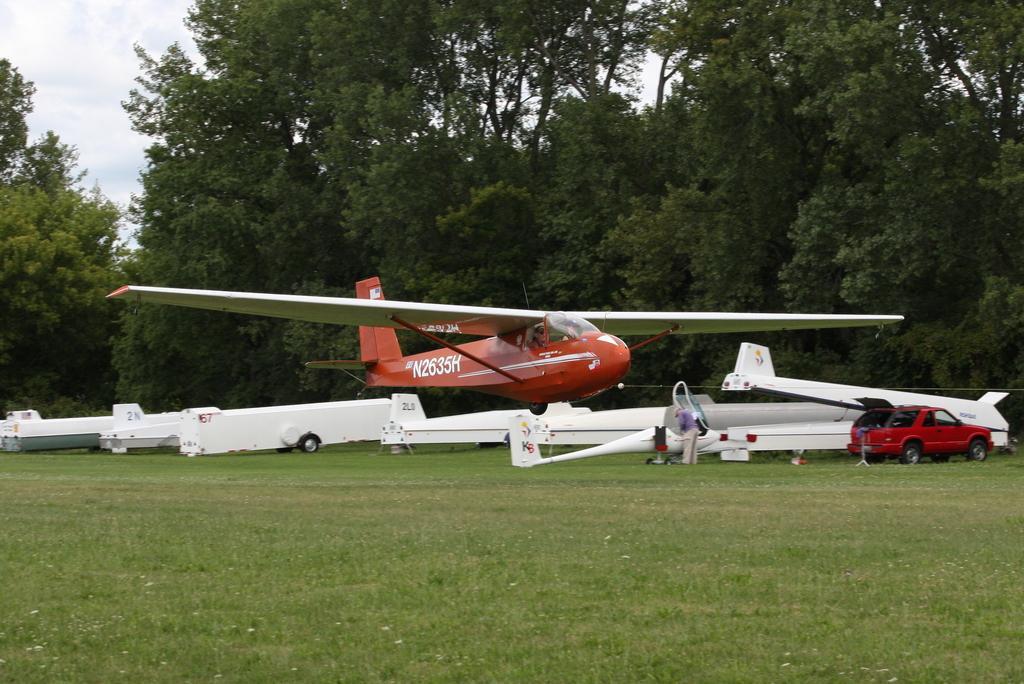In one or two sentences, can you explain what this image depicts? In the image we can see there is an aeroplane flying in the sky and there are other aeroplanes parked on the ground. There is a person standing near the aeroplane and there is a car parked on the road. Behind there are trees. 